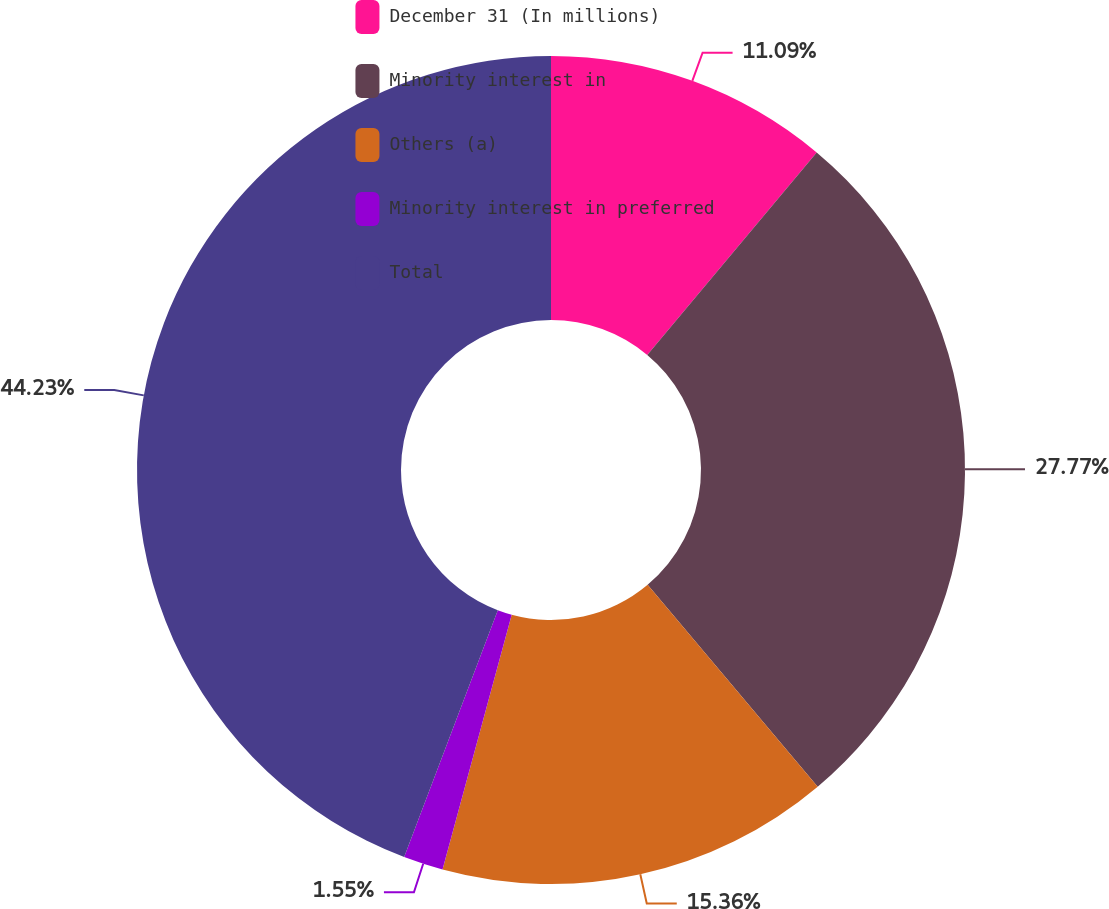Convert chart. <chart><loc_0><loc_0><loc_500><loc_500><pie_chart><fcel>December 31 (In millions)<fcel>Minority interest in<fcel>Others (a)<fcel>Minority interest in preferred<fcel>Total<nl><fcel>11.09%<fcel>27.77%<fcel>15.36%<fcel>1.55%<fcel>44.23%<nl></chart> 